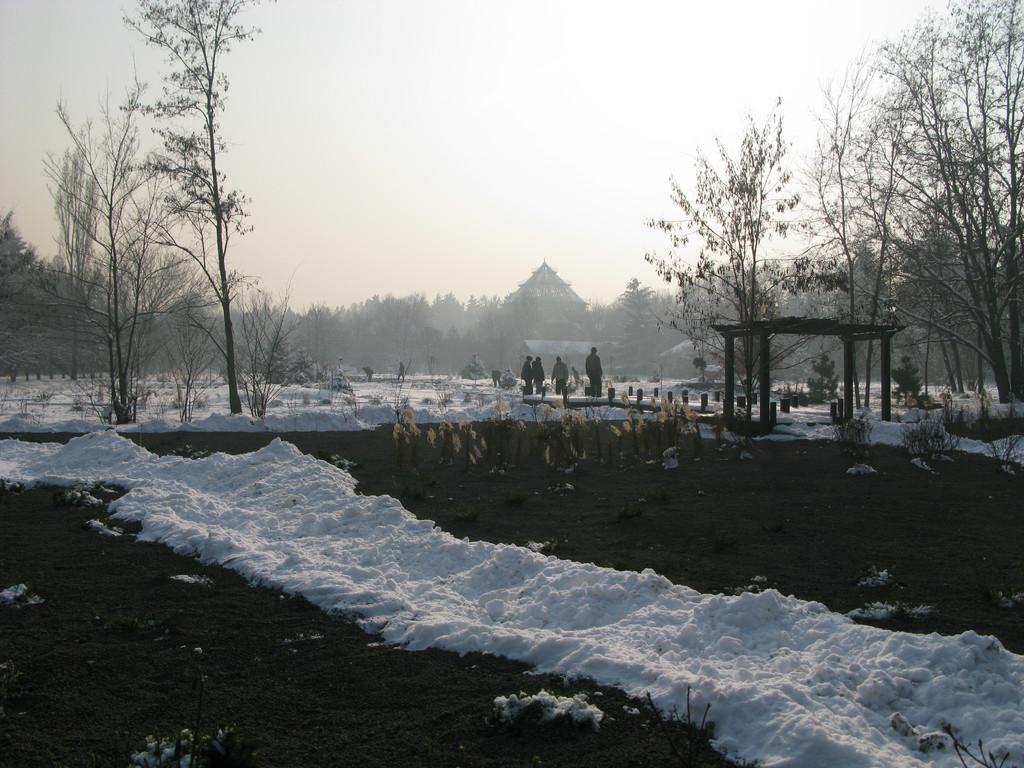Can you describe this image briefly? In this picture we can see people on the ground, here we can see snow, trees, building, house, roof, pillars and we can see sky in the background. 